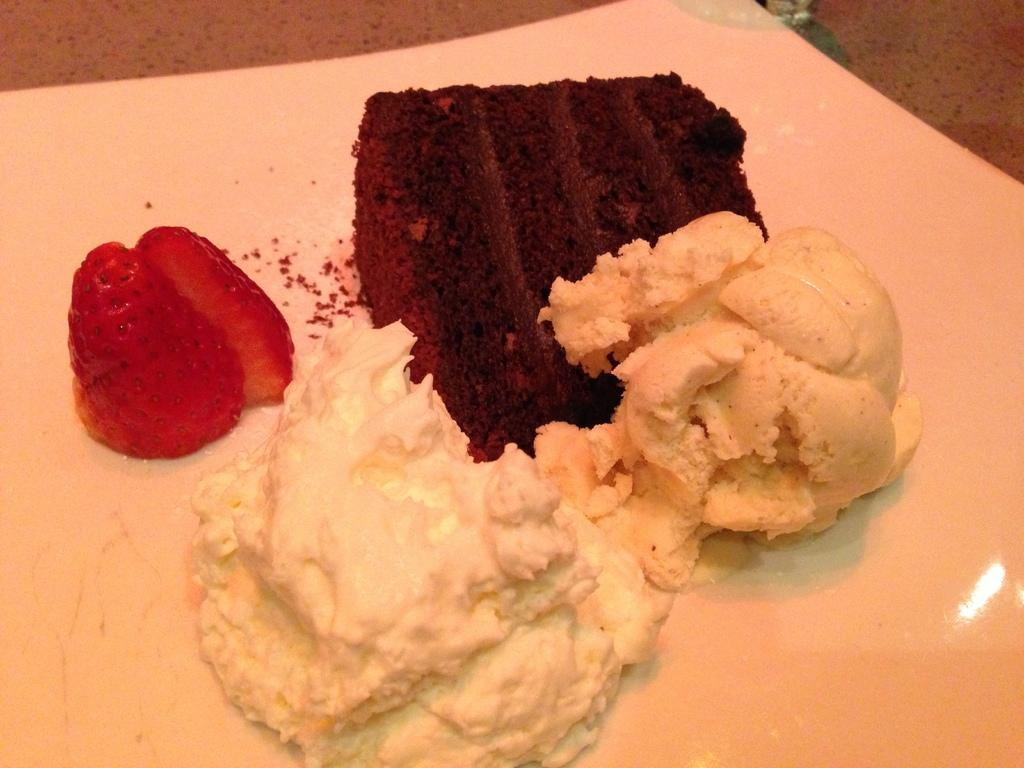What type of food can be seen in the image? There are desserts in the image. Can you describe one specific dessert in the image? There is a strawberry on a plate in the image. Where are the desserts and strawberry located in the image? The desserts and strawberry are placed on a table. What pest is causing the desserts to be infested in the image? There is no indication of any pests or infestation in the image; the desserts appear to be undisturbed. 